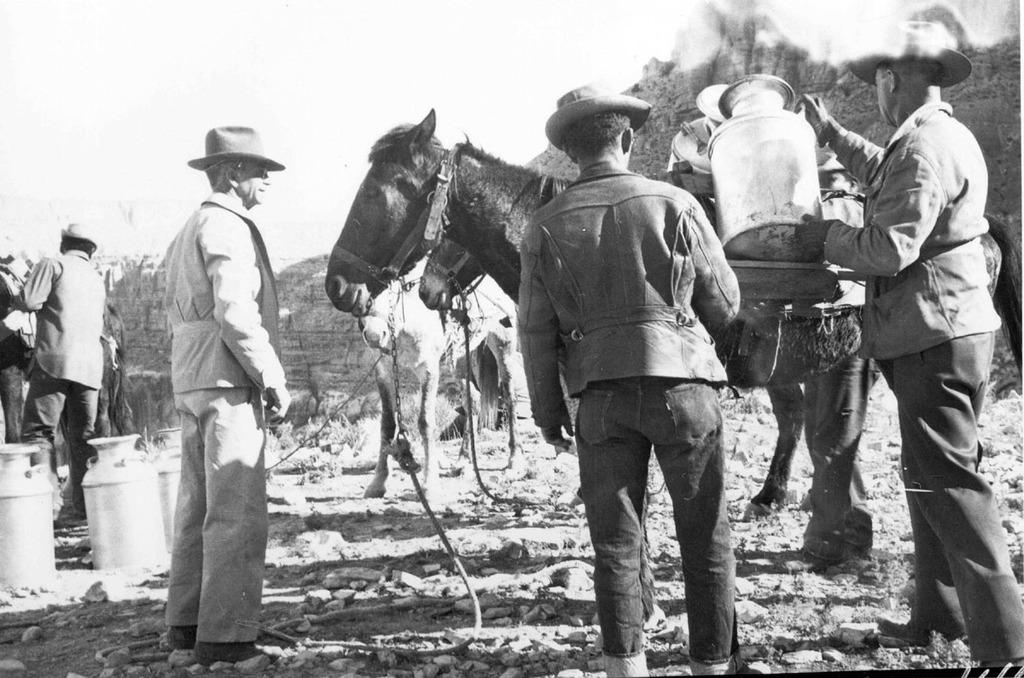Who is present in the image? There are men in the image. What is the men doing in the image? The men are in front of a donkey and keeping jars. How are the jars connected to the donkey? The jars are attached to the donkey. What can be seen in the background of the image? There is a wall in the background of the image. What type of veil is draped over the donkey in the image? There is no veil present in the image; the donkey is not covered by any fabric. 